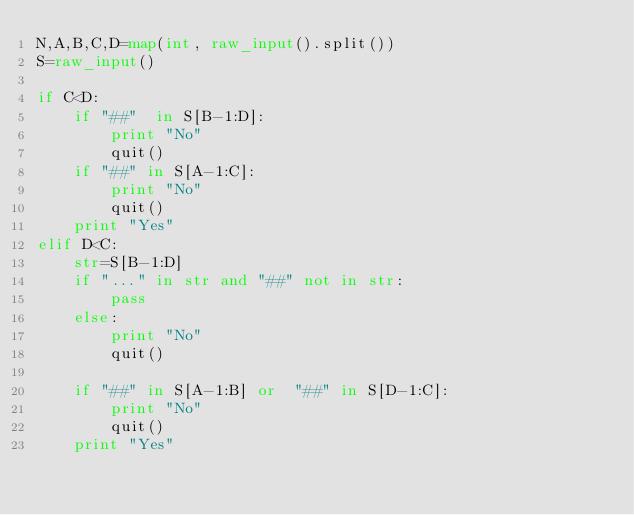Convert code to text. <code><loc_0><loc_0><loc_500><loc_500><_Python_>N,A,B,C,D=map(int, raw_input().split())
S=raw_input()

if C<D:
	if "##"  in S[B-1:D]:
		print "No"
		quit()
	if "##" in S[A-1:C]:
		print "No"
		quit()
	print "Yes"
elif D<C:
	str=S[B-1:D]
	if "..." in str and "##" not in str:
		pass
	else:
		print "No"
		quit()

	if "##" in S[A-1:B] or  "##" in S[D-1:C]:
		print "No"
		quit()
	print "Yes"</code> 